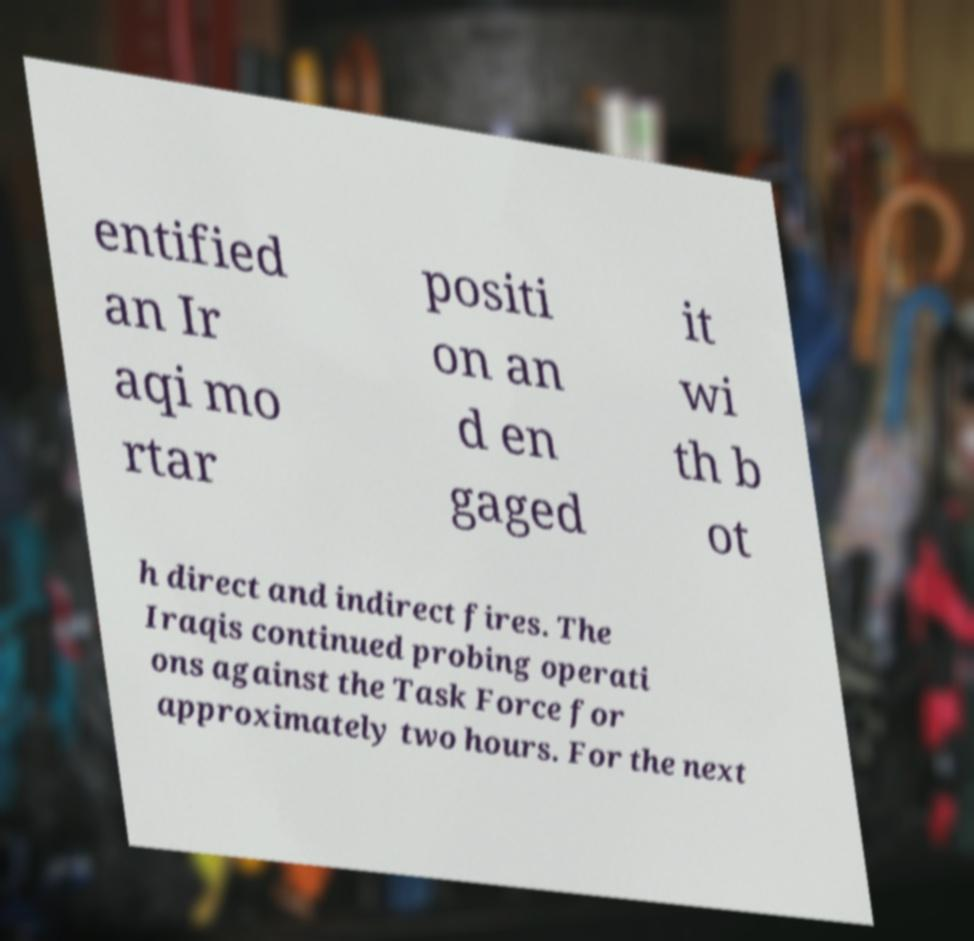Can you read and provide the text displayed in the image?This photo seems to have some interesting text. Can you extract and type it out for me? entified an Ir aqi mo rtar positi on an d en gaged it wi th b ot h direct and indirect fires. The Iraqis continued probing operati ons against the Task Force for approximately two hours. For the next 